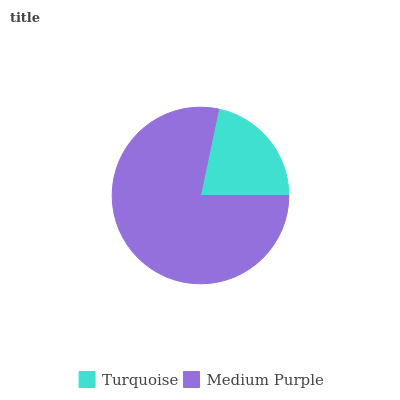Is Turquoise the minimum?
Answer yes or no. Yes. Is Medium Purple the maximum?
Answer yes or no. Yes. Is Medium Purple the minimum?
Answer yes or no. No. Is Medium Purple greater than Turquoise?
Answer yes or no. Yes. Is Turquoise less than Medium Purple?
Answer yes or no. Yes. Is Turquoise greater than Medium Purple?
Answer yes or no. No. Is Medium Purple less than Turquoise?
Answer yes or no. No. Is Medium Purple the high median?
Answer yes or no. Yes. Is Turquoise the low median?
Answer yes or no. Yes. Is Turquoise the high median?
Answer yes or no. No. Is Medium Purple the low median?
Answer yes or no. No. 